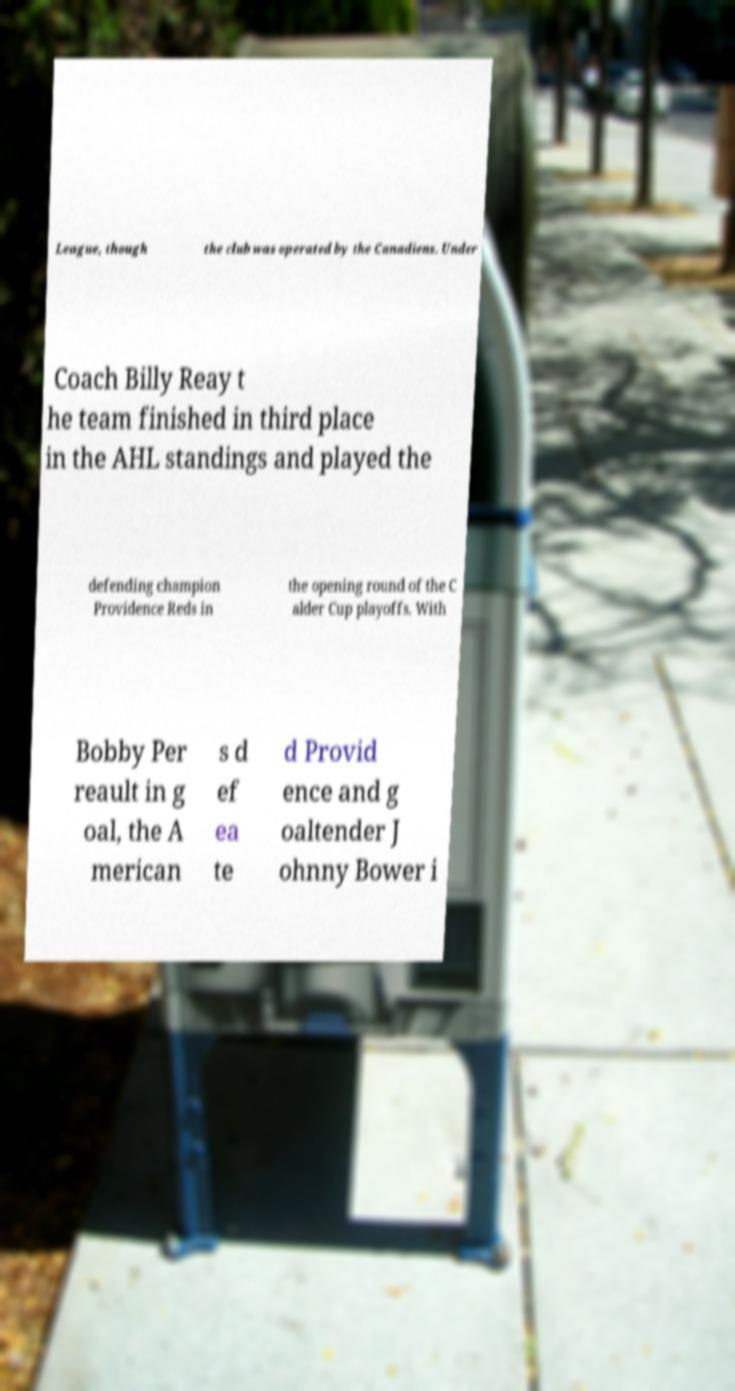There's text embedded in this image that I need extracted. Can you transcribe it verbatim? League, though the club was operated by the Canadiens. Under Coach Billy Reay t he team finished in third place in the AHL standings and played the defending champion Providence Reds in the opening round of the C alder Cup playoffs. With Bobby Per reault in g oal, the A merican s d ef ea te d Provid ence and g oaltender J ohnny Bower i 